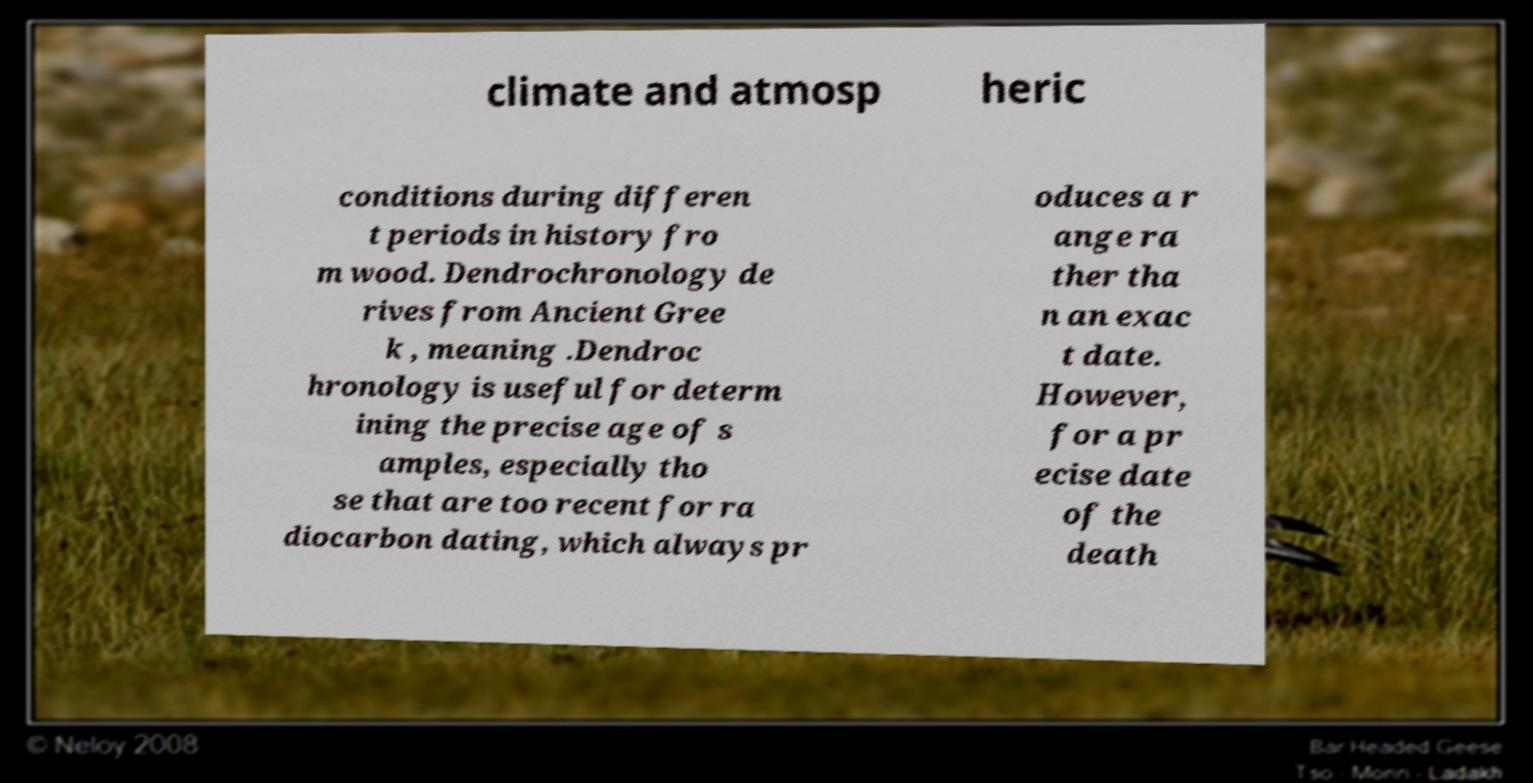I need the written content from this picture converted into text. Can you do that? climate and atmosp heric conditions during differen t periods in history fro m wood. Dendrochronology de rives from Ancient Gree k , meaning .Dendroc hronology is useful for determ ining the precise age of s amples, especially tho se that are too recent for ra diocarbon dating, which always pr oduces a r ange ra ther tha n an exac t date. However, for a pr ecise date of the death 